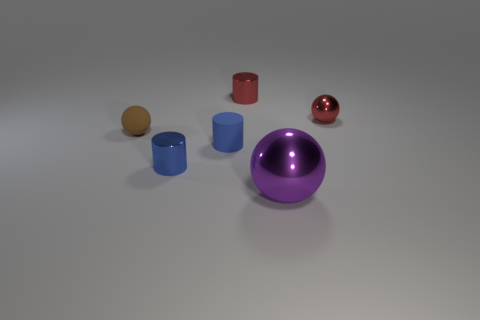Subtract all tiny spheres. How many spheres are left? 1 Subtract 1 spheres. How many spheres are left? 2 Subtract all blue cylinders. How many cylinders are left? 1 Add 3 metallic cylinders. How many objects exist? 9 Add 1 tiny purple cylinders. How many tiny purple cylinders exist? 1 Subtract 0 red blocks. How many objects are left? 6 Subtract all red balls. Subtract all purple cubes. How many balls are left? 2 Subtract all green cylinders. How many red spheres are left? 1 Subtract all small blue objects. Subtract all big purple things. How many objects are left? 3 Add 1 matte spheres. How many matte spheres are left? 2 